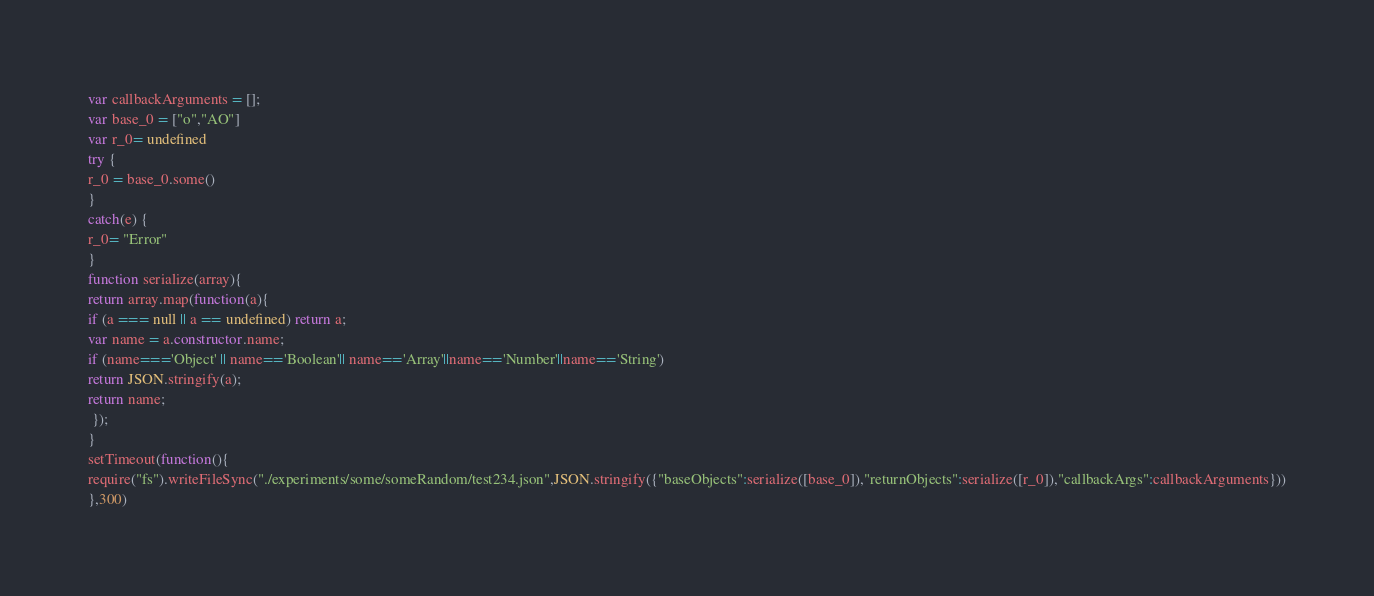<code> <loc_0><loc_0><loc_500><loc_500><_JavaScript_>





var callbackArguments = [];
var base_0 = ["o","AO"]
var r_0= undefined
try {
r_0 = base_0.some()
}
catch(e) {
r_0= "Error"
}
function serialize(array){
return array.map(function(a){
if (a === null || a == undefined) return a;
var name = a.constructor.name;
if (name==='Object' || name=='Boolean'|| name=='Array'||name=='Number'||name=='String')
return JSON.stringify(a);
return name;
 });
}
setTimeout(function(){
require("fs").writeFileSync("./experiments/some/someRandom/test234.json",JSON.stringify({"baseObjects":serialize([base_0]),"returnObjects":serialize([r_0]),"callbackArgs":callbackArguments}))
},300)</code> 